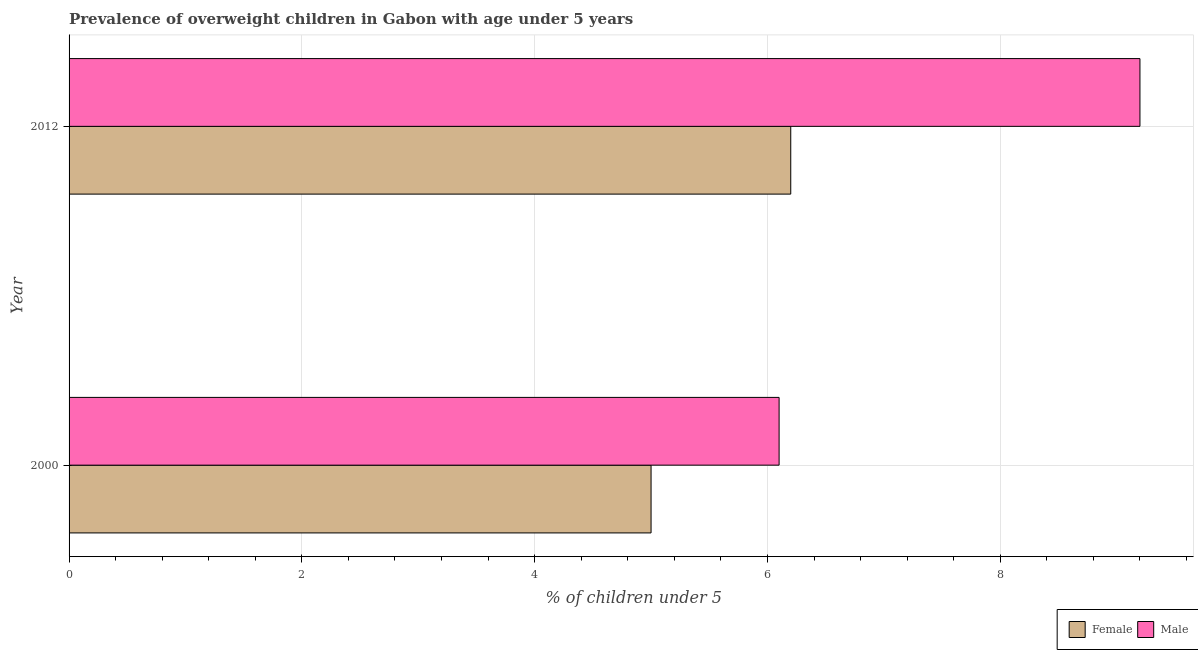How many different coloured bars are there?
Your answer should be compact. 2. How many groups of bars are there?
Make the answer very short. 2. Are the number of bars on each tick of the Y-axis equal?
Offer a terse response. Yes. How many bars are there on the 1st tick from the bottom?
Offer a terse response. 2. What is the percentage of obese male children in 2012?
Make the answer very short. 9.2. Across all years, what is the maximum percentage of obese female children?
Provide a succinct answer. 6.2. Across all years, what is the minimum percentage of obese female children?
Give a very brief answer. 5. In which year was the percentage of obese female children minimum?
Make the answer very short. 2000. What is the total percentage of obese male children in the graph?
Ensure brevity in your answer.  15.3. What is the difference between the percentage of obese female children in 2000 and the percentage of obese male children in 2012?
Keep it short and to the point. -4.2. What is the average percentage of obese female children per year?
Provide a short and direct response. 5.6. In the year 2012, what is the difference between the percentage of obese female children and percentage of obese male children?
Provide a short and direct response. -3. What is the ratio of the percentage of obese male children in 2000 to that in 2012?
Your response must be concise. 0.66. Is the percentage of obese female children in 2000 less than that in 2012?
Ensure brevity in your answer.  Yes. Is the difference between the percentage of obese male children in 2000 and 2012 greater than the difference between the percentage of obese female children in 2000 and 2012?
Ensure brevity in your answer.  No. What does the 2nd bar from the top in 2000 represents?
Provide a succinct answer. Female. What does the 2nd bar from the bottom in 2012 represents?
Your answer should be very brief. Male. How many bars are there?
Offer a very short reply. 4. Are all the bars in the graph horizontal?
Your answer should be very brief. Yes. How many years are there in the graph?
Your answer should be very brief. 2. Are the values on the major ticks of X-axis written in scientific E-notation?
Your response must be concise. No. What is the title of the graph?
Your answer should be compact. Prevalence of overweight children in Gabon with age under 5 years. What is the label or title of the X-axis?
Keep it short and to the point.  % of children under 5. What is the  % of children under 5 in Female in 2000?
Make the answer very short. 5. What is the  % of children under 5 of Male in 2000?
Ensure brevity in your answer.  6.1. What is the  % of children under 5 in Female in 2012?
Ensure brevity in your answer.  6.2. What is the  % of children under 5 in Male in 2012?
Keep it short and to the point. 9.2. Across all years, what is the maximum  % of children under 5 in Female?
Offer a very short reply. 6.2. Across all years, what is the maximum  % of children under 5 of Male?
Keep it short and to the point. 9.2. Across all years, what is the minimum  % of children under 5 of Female?
Your answer should be compact. 5. Across all years, what is the minimum  % of children under 5 of Male?
Provide a short and direct response. 6.1. What is the total  % of children under 5 in Female in the graph?
Offer a very short reply. 11.2. What is the difference between the  % of children under 5 of Female in 2000 and that in 2012?
Make the answer very short. -1.2. What is the difference between the  % of children under 5 of Female in 2000 and the  % of children under 5 of Male in 2012?
Your response must be concise. -4.2. What is the average  % of children under 5 in Male per year?
Make the answer very short. 7.65. In the year 2000, what is the difference between the  % of children under 5 in Female and  % of children under 5 in Male?
Provide a succinct answer. -1.1. What is the ratio of the  % of children under 5 of Female in 2000 to that in 2012?
Your answer should be compact. 0.81. What is the ratio of the  % of children under 5 in Male in 2000 to that in 2012?
Keep it short and to the point. 0.66. What is the difference between the highest and the second highest  % of children under 5 in Female?
Give a very brief answer. 1.2. What is the difference between the highest and the second highest  % of children under 5 in Male?
Provide a short and direct response. 3.1. What is the difference between the highest and the lowest  % of children under 5 of Female?
Make the answer very short. 1.2. What is the difference between the highest and the lowest  % of children under 5 in Male?
Ensure brevity in your answer.  3.1. 